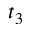Convert formula to latex. <formula><loc_0><loc_0><loc_500><loc_500>t _ { 3 }</formula> 